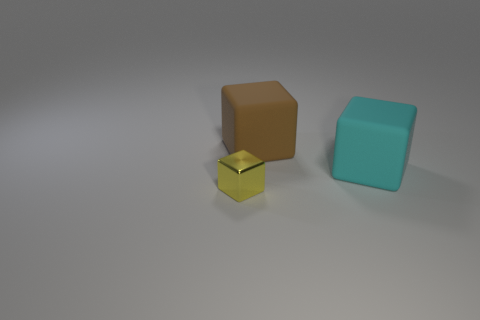What material is the small yellow block left of the large cyan matte thing? The small yellow block appears to have a reflective surface, not necessarily indicating it is metal without context or additional information, but it could be a polished plastic or a metal with a gold-tone finish used for decorative purposes or as a toy. 